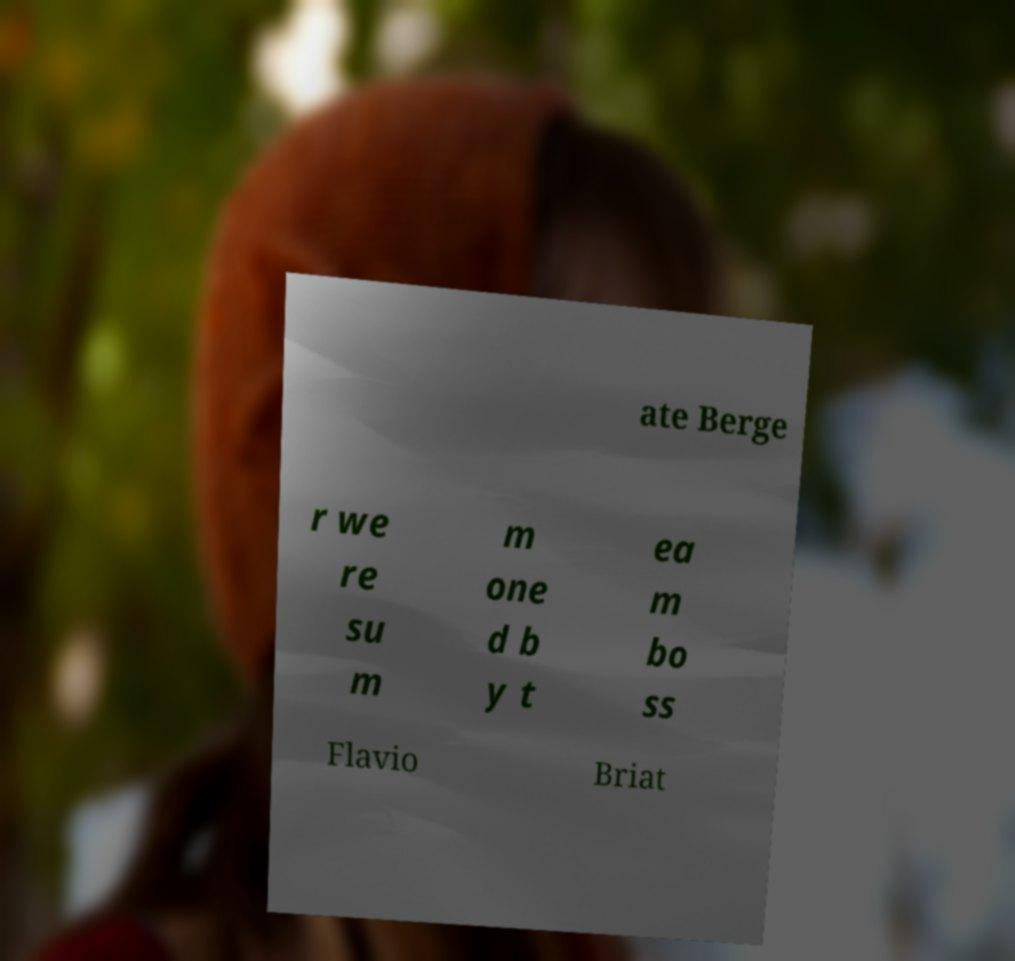Could you extract and type out the text from this image? ate Berge r we re su m m one d b y t ea m bo ss Flavio Briat 